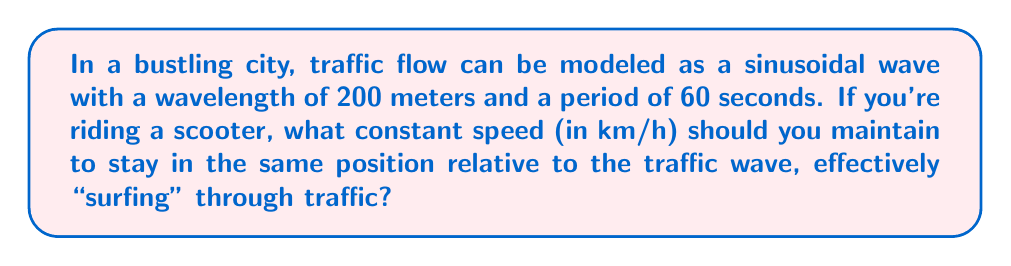What is the answer to this math problem? Let's approach this step-by-step:

1) The wave equation for a traveling wave is:

   $$y(x,t) = A \sin(kx - \omega t)$$

   where $k$ is the wave number and $\omega$ is the angular frequency.

2) We're given the wavelength $\lambda = 200$ m and the period $T = 60$ s.

3) The wave number $k$ is related to the wavelength by:

   $$k = \frac{2\pi}{\lambda} = \frac{2\pi}{200} = \frac{\pi}{100} \text{ m}^{-1}$$

4) The angular frequency $\omega$ is related to the period by:

   $$\omega = \frac{2\pi}{T} = \frac{2\pi}{60} = \frac{\pi}{30} \text{ s}^{-1}$$

5) The phase velocity of the wave (which is the speed we want) is given by:

   $$v = \frac{\omega}{k} = \frac{\pi/30}{\pi/100} = \frac{100}{30} = \frac{10}{3} \text{ m/s}$$

6) Convert this to km/h:

   $$v = \frac{10}{3} \cdot \frac{3600}{1000} = 12 \text{ km/h}$$

Therefore, to "surf" the traffic wave, you should maintain a constant speed of 12 km/h on your scooter.
Answer: 12 km/h 